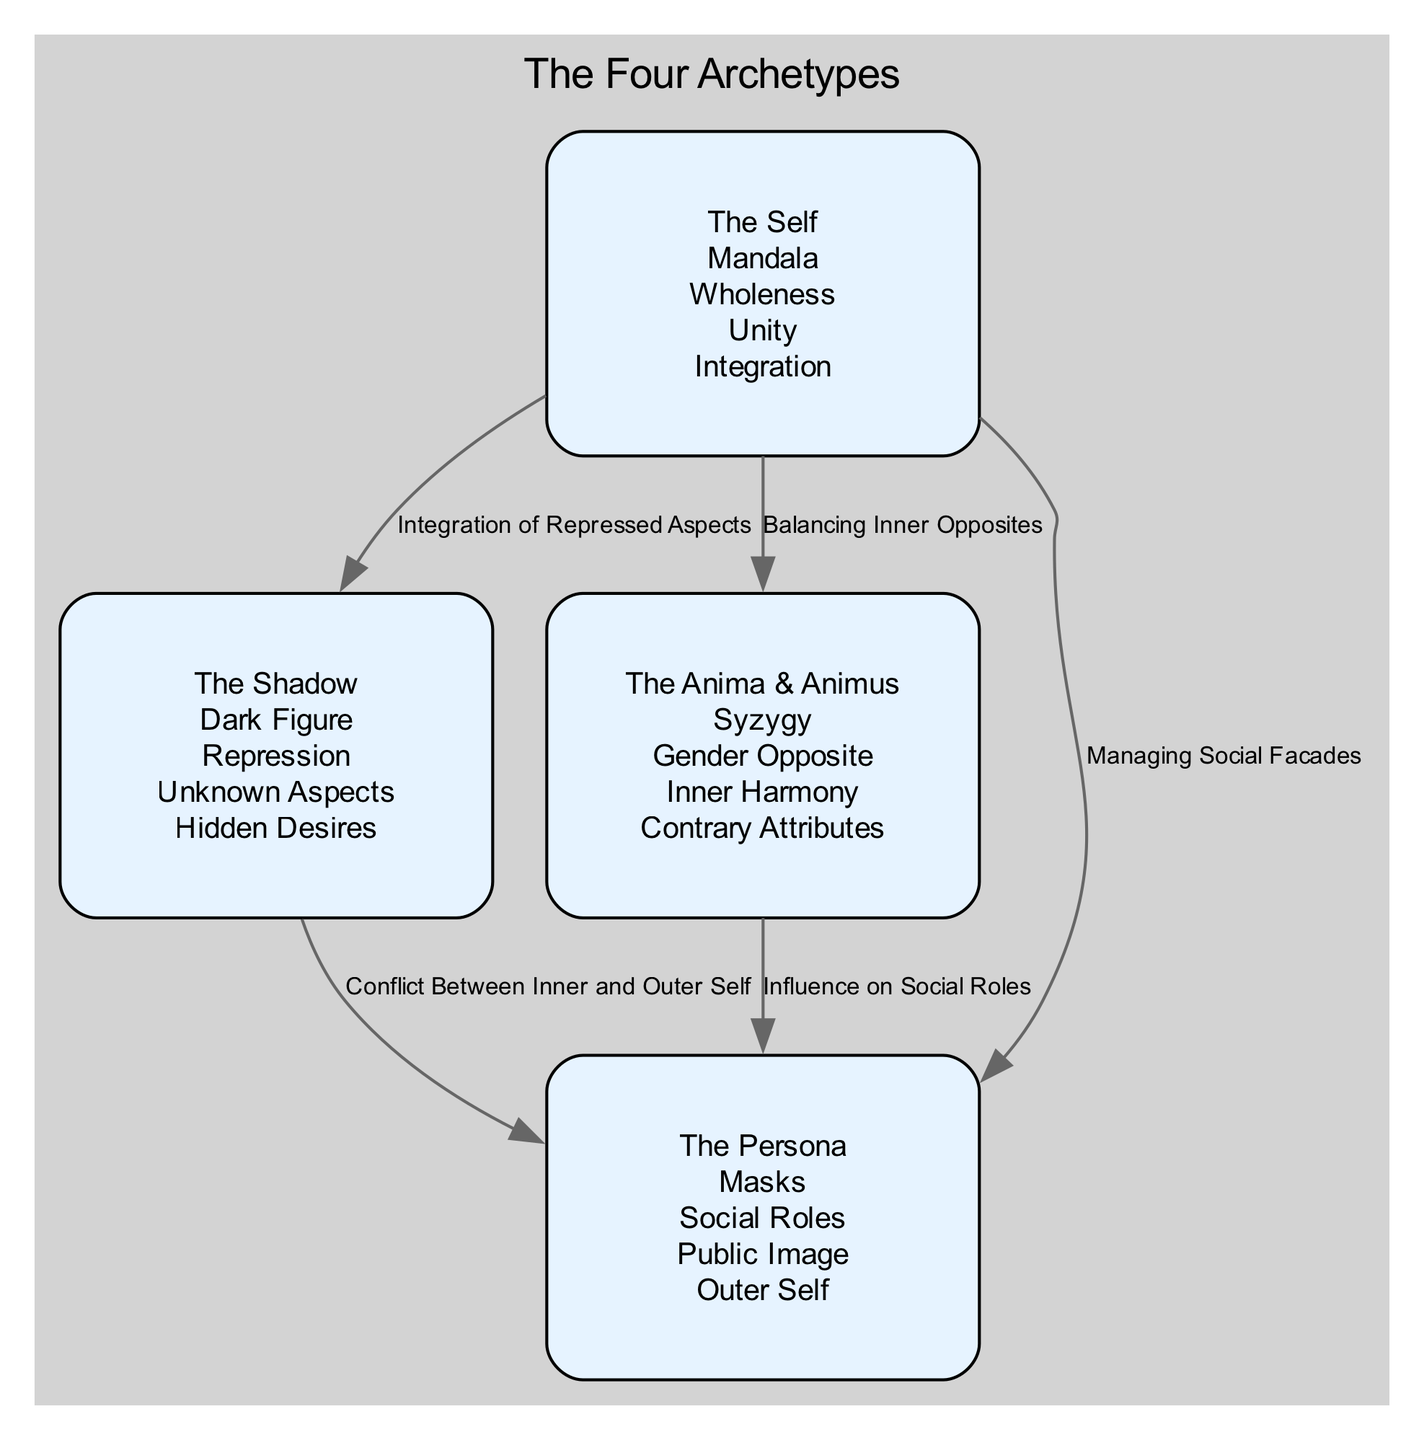What is the symbol for The Self? The symbol for The Self is a Mandala, as indicated in the diagram.
Answer: Mandala How many key characteristics are listed for The Persona? The diagram shows three key characteristics for The Persona: Social Roles, Public Image, and Outer Self. Counting these gives us three.
Answer: 3 What type of relationship exists between The Shadow and The Persona? The diagram indicates a connection labeled "Conflict Between Inner and Outer Self," showing a direct relationship between The Shadow and The Persona.
Answer: Conflict Between Inner and Outer Self Which archetype is associated with the symbol Syzygy? The diagram specifies that the Anima & Animus archetype is represented by the symbol Syzygy.
Answer: The Anima & Animus What are the key characteristics of The Shadow? The key characteristics listed for The Shadow in the diagram are: Repression, Unknown Aspects, and Hidden Desires. So, combining these gives us three distinct characteristics.
Answer: Repression, Unknown Aspects, Hidden Desires Which archetype relates to managing social facades? The diagram explicitly connects The Self to the concept of managing social facades, indicating a relationship with The Persona.
Answer: The Persona How many total archetypes are represented in the diagram? The diagram displays four distinct archetypes: The Self, The Shadow, The Anima & Animus, and The Persona, thus we have a total of four archetypes.
Answer: 4 What is one characteristic of The Anima & Animus? The diagram lists several characteristics for The Anima & Animus; one of them is Inner Harmony, which illustrates the concept well.
Answer: Inner Harmony Which archetype connects with "Balancing Inner Opposites"? According to the diagram, the relationship of "Balancing Inner Opposites" is specifically associated with The Self and The Anima & Animus.
Answer: The Anima & Animus 